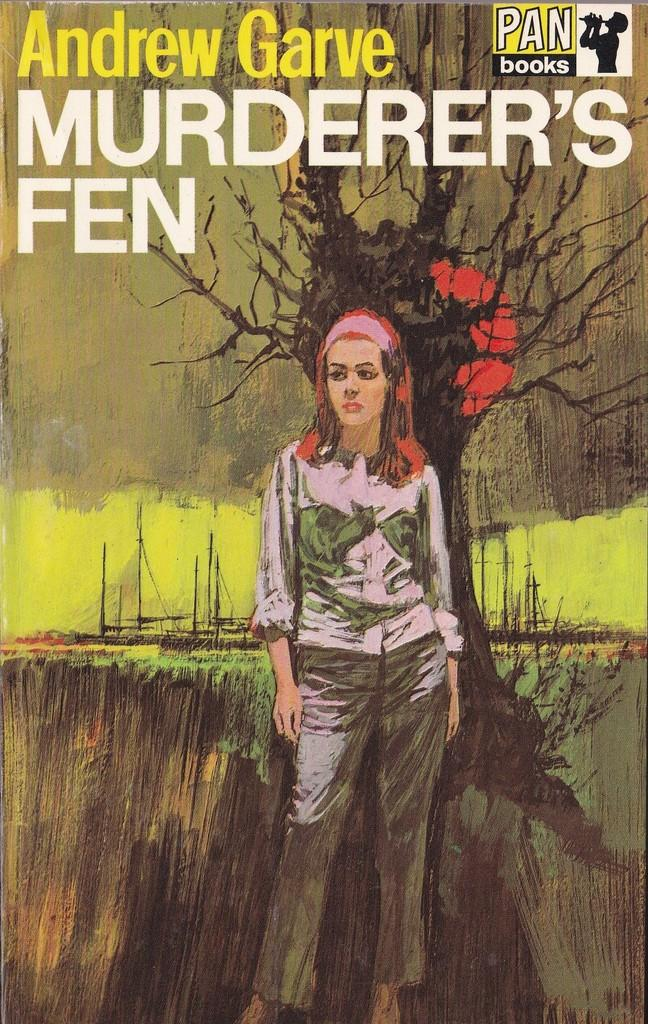What is the main subject of the image? The main subject of the image is a woman standing in the middle of the image. What can be seen in the background of the image? There are trees visible in the background of the image. What is the context of the image? The image might be a painting in a book. Is there any text present in the image? There is text written in the book. Can you see a hole in the cushion that the woman is sitting on in the image? There is no cushion or hole present in the image; it features a woman standing in the middle of the image with trees in the background. Is there a baby visible in the image? There is no baby present in the image; it features a woman standing in the middle of the image with trees in the background. 